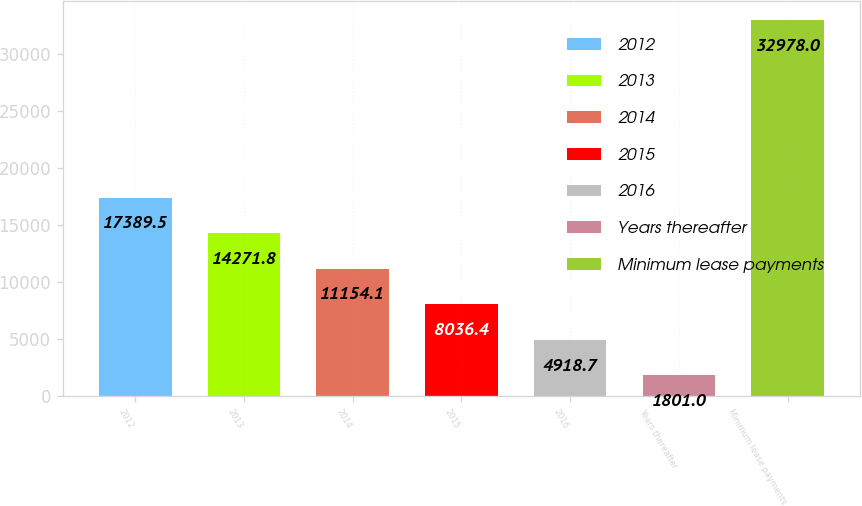<chart> <loc_0><loc_0><loc_500><loc_500><bar_chart><fcel>2012<fcel>2013<fcel>2014<fcel>2015<fcel>2016<fcel>Years thereafter<fcel>Minimum lease payments<nl><fcel>17389.5<fcel>14271.8<fcel>11154.1<fcel>8036.4<fcel>4918.7<fcel>1801<fcel>32978<nl></chart> 